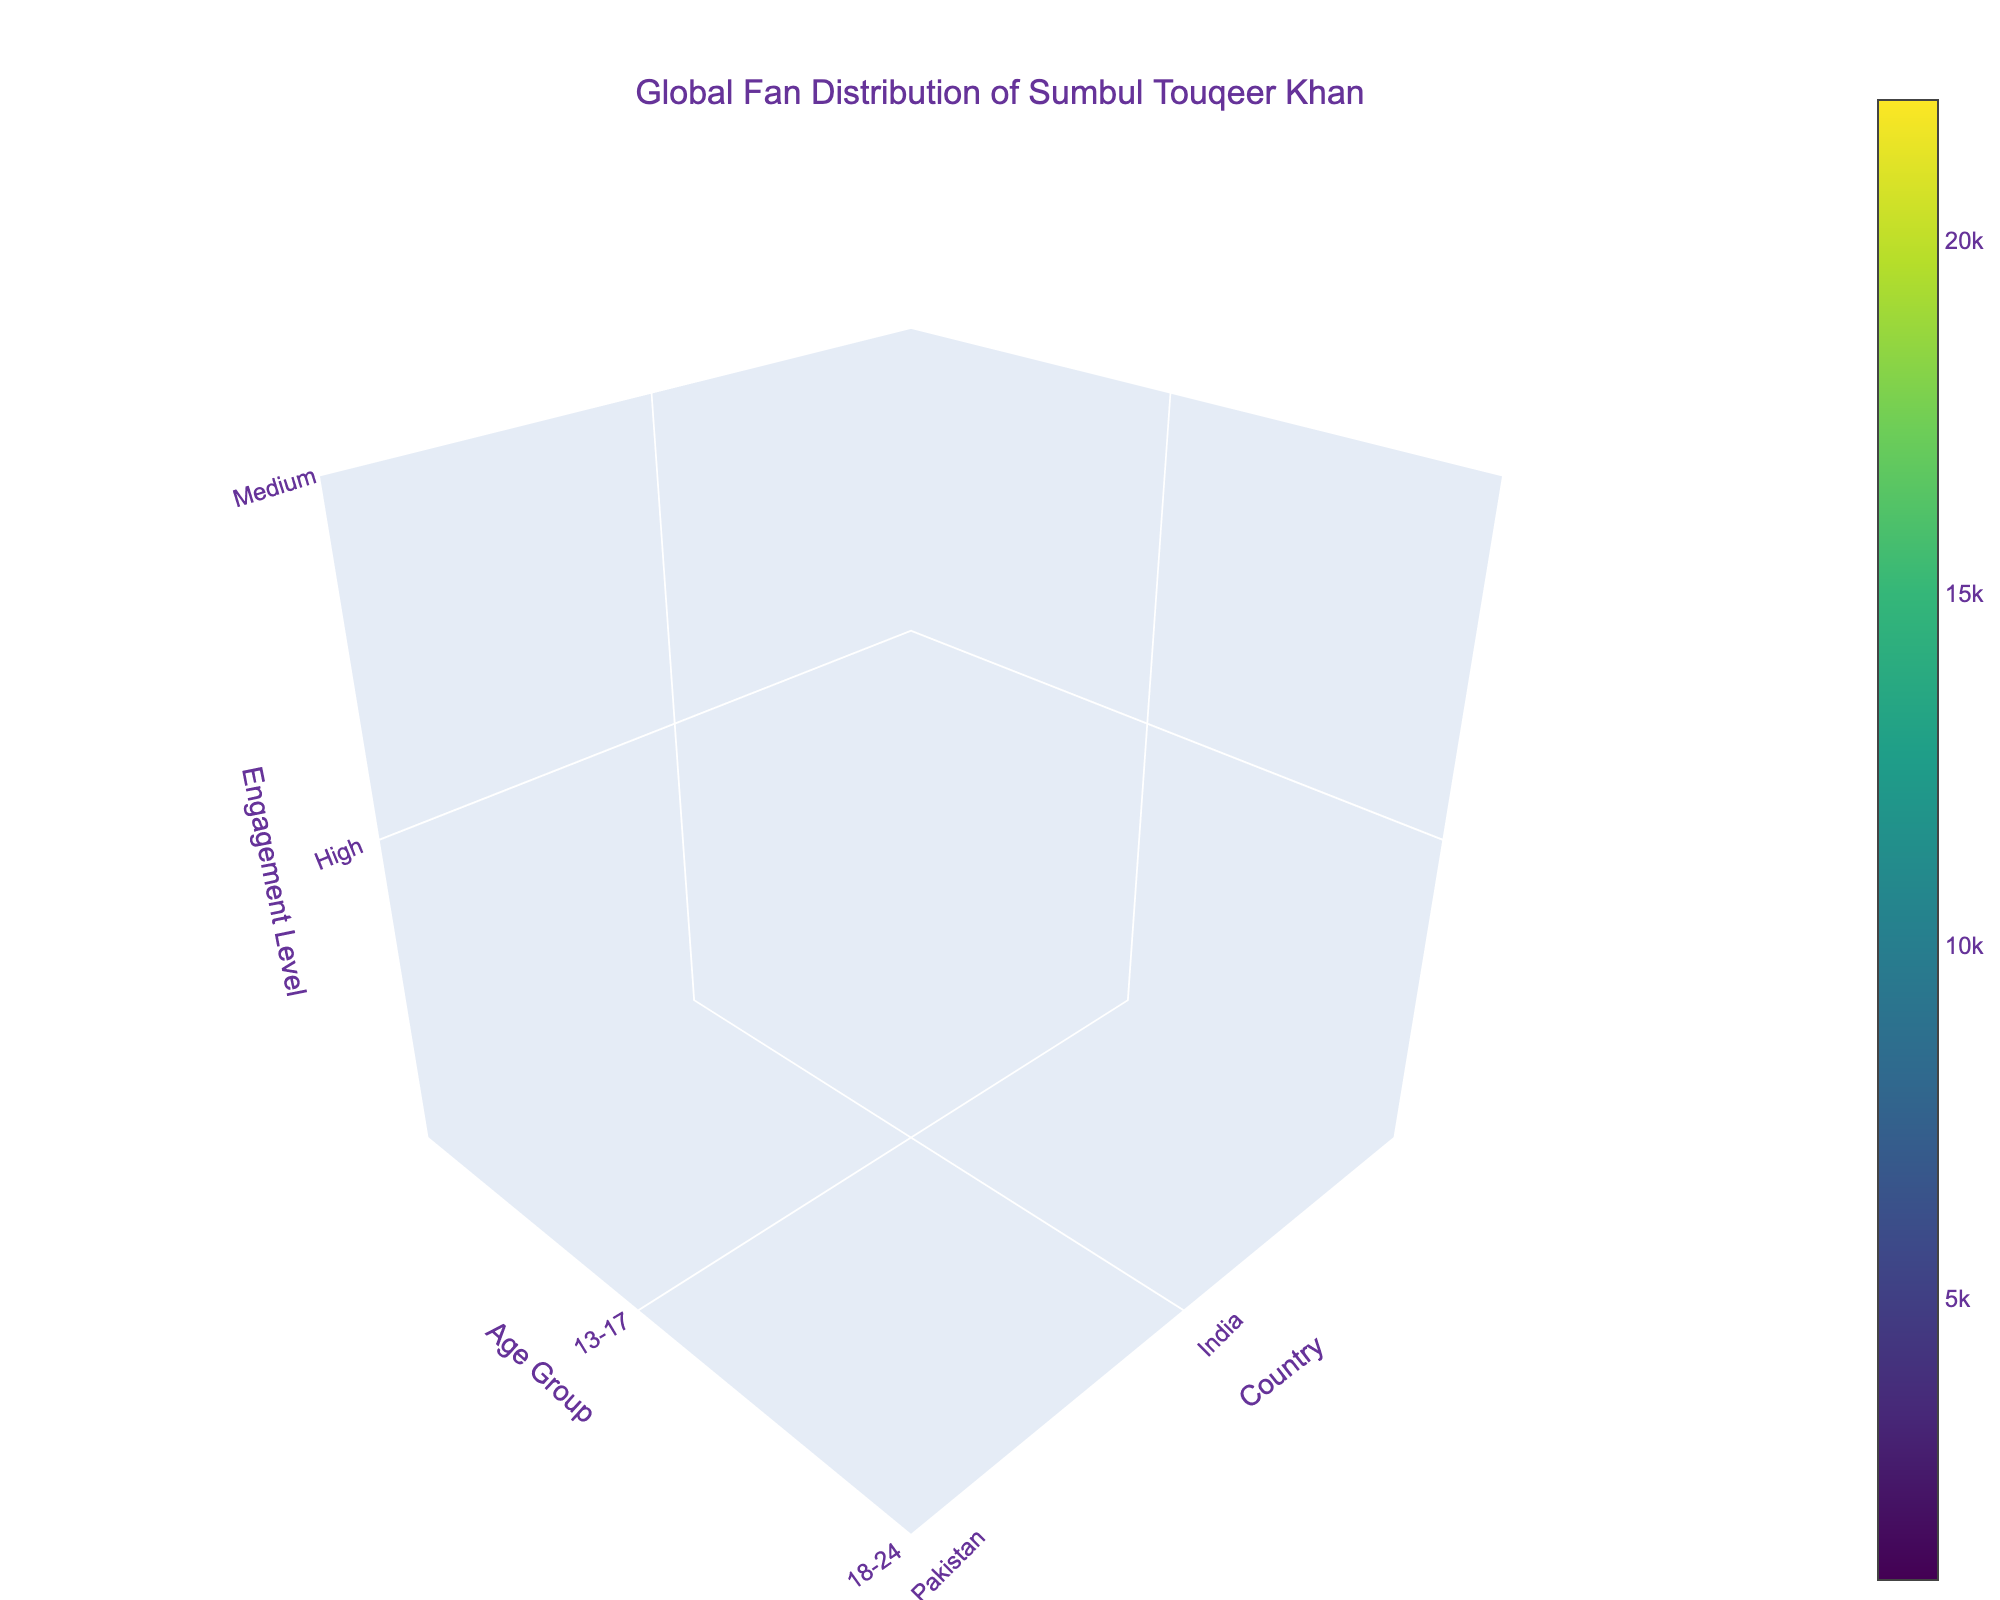What's the title of the plot? The title is usually displayed at the top of the plot and indicates the main topic or subject the plot is about. In this case, the title is given as "Global Fan Distribution of Sumbul Touqeer Khan".
Answer: Global Fan Distribution of Sumbul Touqeer Khan What are the axes labels in the plot? The axes labels help in understanding what the x-axis, y-axis, and z-axis represent. For this plot, they are 'Country', 'Age Group', and 'Engagement Level' respectively.
Answer: Country, Age Group, Engagement Level Which country has the highest engagement level in the 13-17 age group? By examining the high engagement levels marked for each country in the 13-17 age group, we see that India has 15,000 fans and Pakistan has 8,000 fans. India has the highest engagement level.
Answer: India What is the sum of fan count for the 18-24 age group across all countries? To find this, we add up the fan counts for the 18-24 age group: 22,000 (India) + 12,000 (Pakistan) + 7,000 (Bangladesh) + 4,000 (United Arab Emirates) + 2,500 (United States) + 2,000 (Sri Lanka) + 1,000 (Australia) = 50,500.
Answer: 50,500 Which age group has the highest number of high engagement fans in India? By comparing the fan counts in the high engagement level category for different age groups in India, we see 13-17 has 15,000 fans and 18-24 has 22,000 fans. Hence, 18-24 has the highest number.
Answer: 18-24 Which countries have low fan engagement in the 25-34 age group? By looking at the 25-34 age group and identifying countries with low engagement, we see that the United Kingdom and Canada both have low engagement levels, with 3,000 and 1,500 fans respectively.
Answer: United Kingdom, Canada What is the total number of medium engagement fans in Bangladesh? By adding the fan counts with medium engagement level, we get 18-24 (7000) and 25-34 (5000), which total to 12,000.
Answer: 12,000 How does the fan count in Nepal for the 13-17 age group compare to that in Malaysia? The fan count for the 13-17 age group in Nepal is 3,500 and in Malaysia is 1,800. Comparing these, Nepal has a higher fan count.
Answer: Nepal What's the average number of high engagement fans in the 13-17 age group across all countries? Only two countries have high engagement fans in the 13-17 age group, India with 15,000 and Pakistan with 8,000. The average is (15,000 + 8,000) / 2 = 11,500.
Answer: 11,500 Which country has the lowest number of fans in the 18-24 age group? By looking at the fan counts for the 18-24 age group across all countries, Australia has the lowest with 1,000 fans.
Answer: Australia 